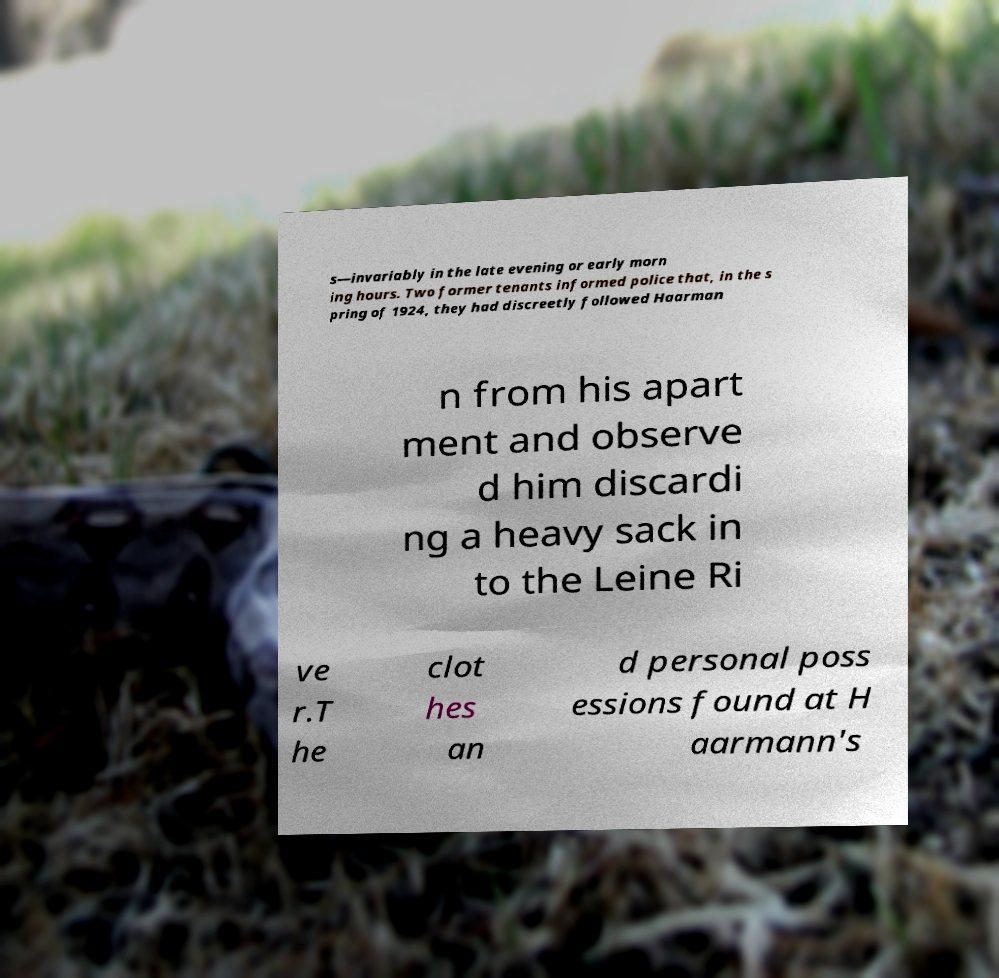I need the written content from this picture converted into text. Can you do that? s—invariably in the late evening or early morn ing hours. Two former tenants informed police that, in the s pring of 1924, they had discreetly followed Haarman n from his apart ment and observe d him discardi ng a heavy sack in to the Leine Ri ve r.T he clot hes an d personal poss essions found at H aarmann's 